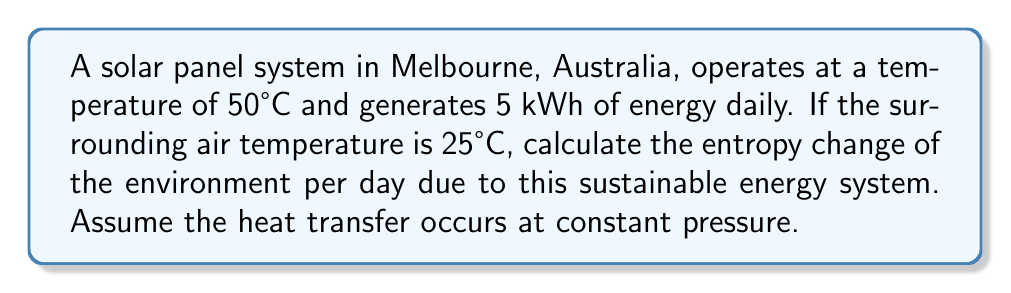Help me with this question. To calculate the entropy change of the environment, we need to consider the heat transfer from the solar panel to the surroundings. The entropy change is given by the equation:

$$\Delta S = \frac{Q}{T}$$

Where:
$\Delta S$ is the entropy change
$Q$ is the heat transferred
$T$ is the temperature of the system receiving the heat (in Kelvin)

Steps:
1. Convert temperatures to Kelvin:
   Solar panel: $T_h = 50°C + 273.15 = 323.15 K$
   Surroundings: $T_c = 25°C + 273.15 = 298.15 K$

2. Calculate the heat transferred:
   The energy generated by the solar panel (5 kWh) is equal to the heat transferred to the environment.
   $Q = 5 \text{ kWh} = 5 \times 3600 \text{ kJ} = 18000 \text{ kJ}$

3. Calculate the entropy change of the environment:
   $$\Delta S_{env} = \frac{Q}{T_c} = \frac{18000 \text{ kJ}}{298.15 \text{ K}} = 60.37 \text{ kJ/K}$$

4. Convert to SI units:
   $$\Delta S_{env} = 60.37 \times 10^3 \text{ J/K} = 60370 \text{ J/K}$$

The positive entropy change indicates that the entropy of the environment increases, which is consistent with the second law of thermodynamics.
Answer: 60370 J/K 